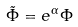Convert formula to latex. <formula><loc_0><loc_0><loc_500><loc_500>\tilde { \Phi } = e ^ { \alpha } \Phi</formula> 